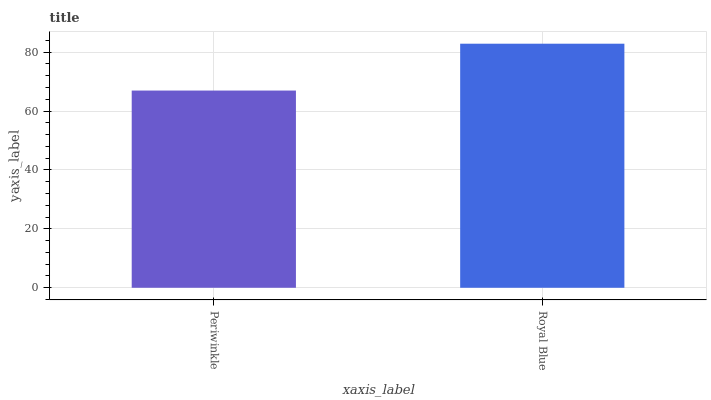Is Periwinkle the minimum?
Answer yes or no. Yes. Is Royal Blue the maximum?
Answer yes or no. Yes. Is Royal Blue the minimum?
Answer yes or no. No. Is Royal Blue greater than Periwinkle?
Answer yes or no. Yes. Is Periwinkle less than Royal Blue?
Answer yes or no. Yes. Is Periwinkle greater than Royal Blue?
Answer yes or no. No. Is Royal Blue less than Periwinkle?
Answer yes or no. No. Is Royal Blue the high median?
Answer yes or no. Yes. Is Periwinkle the low median?
Answer yes or no. Yes. Is Periwinkle the high median?
Answer yes or no. No. Is Royal Blue the low median?
Answer yes or no. No. 